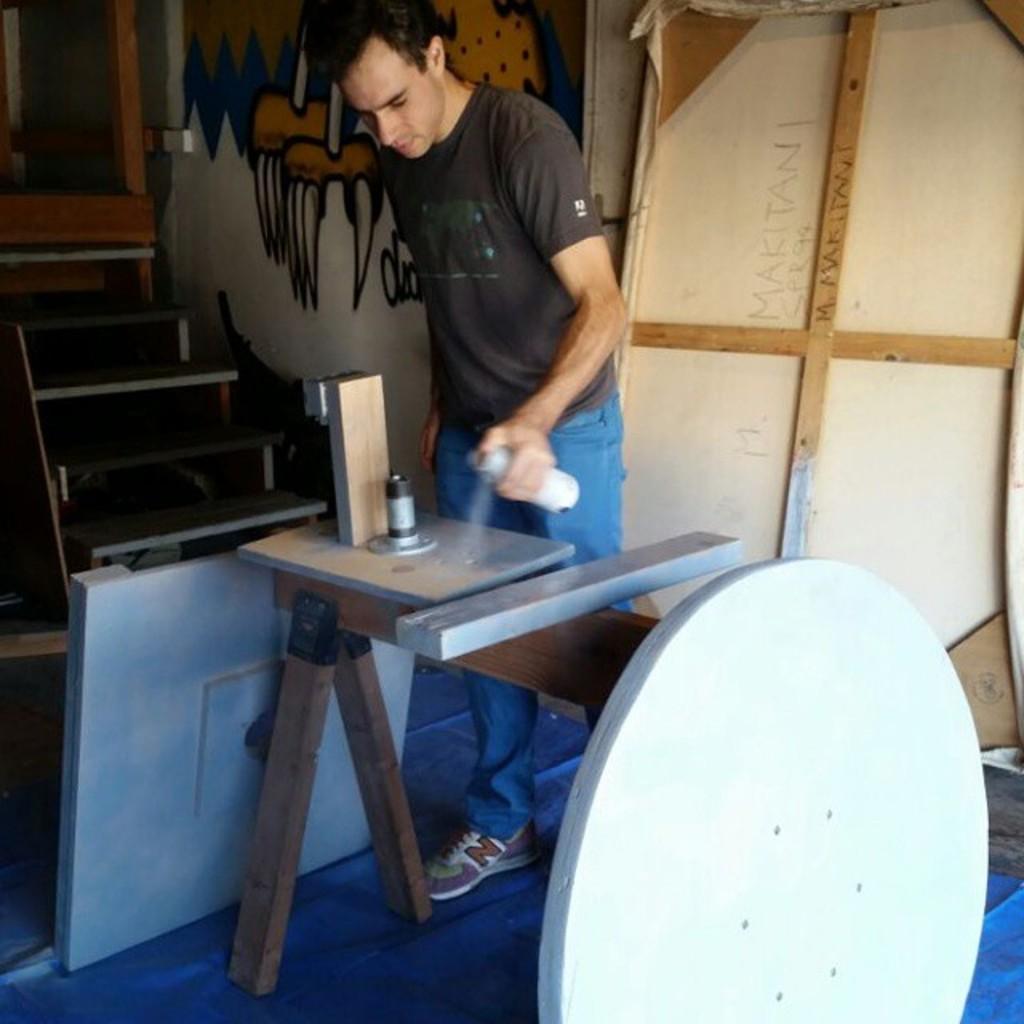Please provide a concise description of this image. In this picture a man spraying paint to the metal 